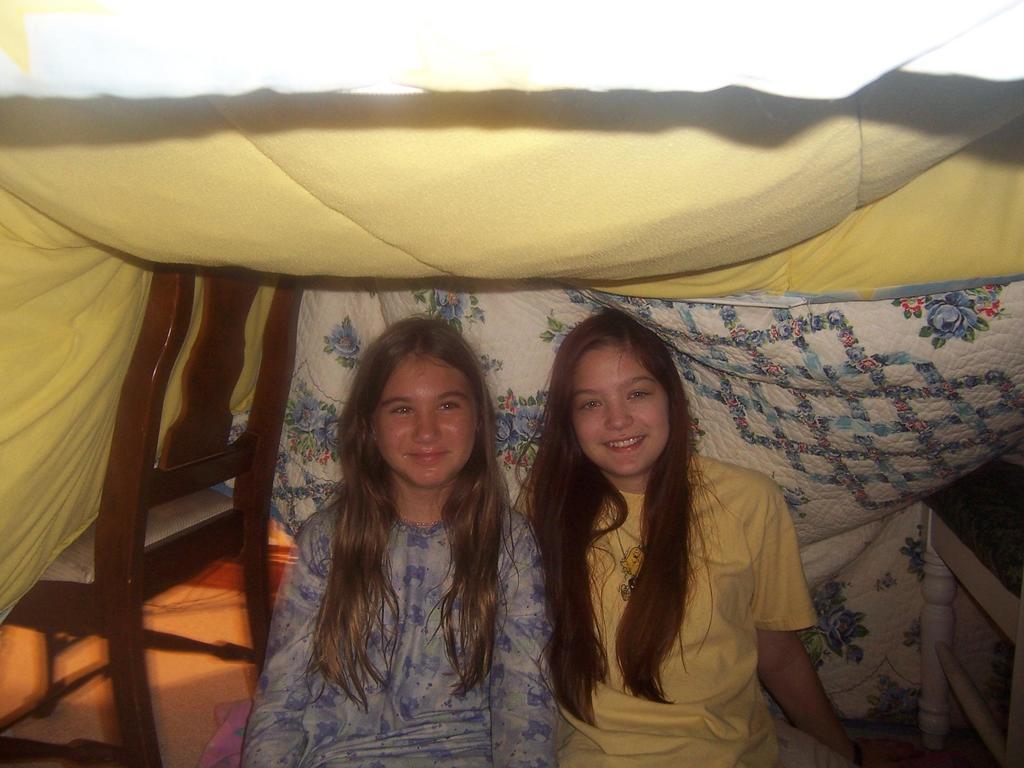Please provide a concise description of this image. This image is taken in a tent. At the top of the image there is a tent. In the middle of the image two girls are sitting on the floor and they are with smiling faces. On the left side of the image there is an empty chair. 